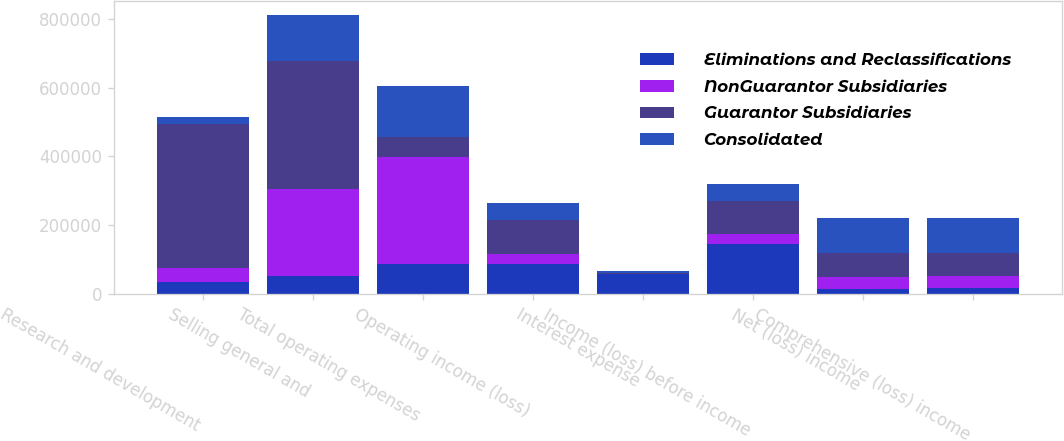Convert chart. <chart><loc_0><loc_0><loc_500><loc_500><stacked_bar_chart><ecel><fcel>Research and development<fcel>Selling general and<fcel>Total operating expenses<fcel>Operating income (loss)<fcel>Interest expense<fcel>Income (loss) before income<fcel>Net (loss) income<fcel>Comprehensive (loss) income<nl><fcel>Eliminations and Reclassifications<fcel>35379<fcel>53465<fcel>88844<fcel>88844<fcel>57344<fcel>146188<fcel>16558<fcel>17731<nl><fcel>NonGuarantor Subsidiaries<fcel>40918<fcel>253531<fcel>310514<fcel>26872<fcel>2619<fcel>29136<fcel>33961<fcel>34014<nl><fcel>Guarantor Subsidiaries<fcel>416869<fcel>370812<fcel>57344<fcel>99060<fcel>3129<fcel>94691<fcel>68718<fcel>67492<nl><fcel>Consolidated<fcel>22330<fcel>132220<fcel>147995<fcel>50971<fcel>4213<fcel>49666<fcel>102679<fcel>101506<nl></chart> 